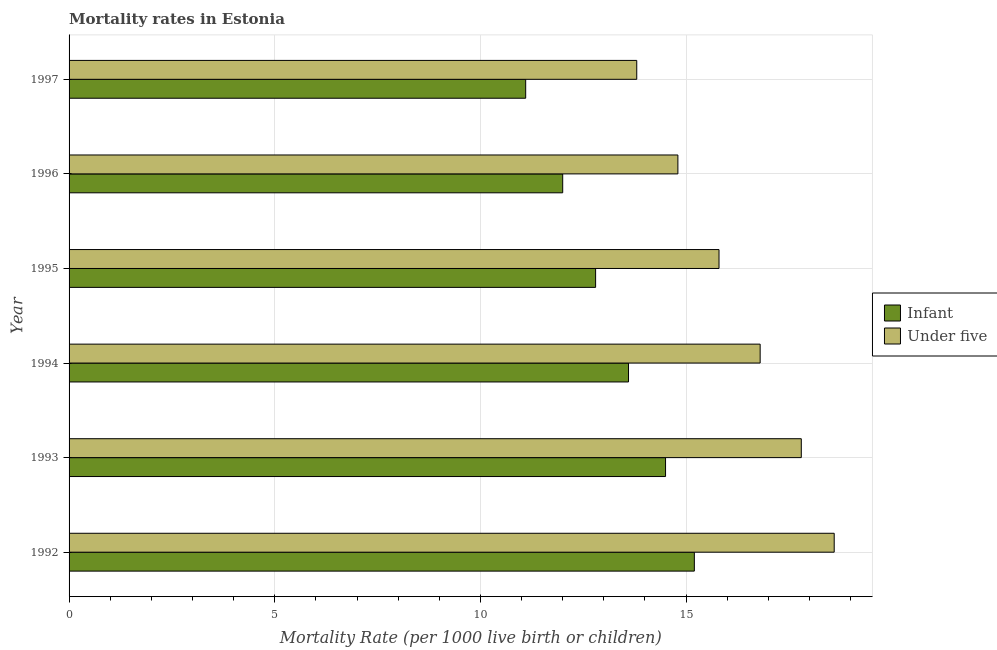How many different coloured bars are there?
Give a very brief answer. 2. Are the number of bars per tick equal to the number of legend labels?
Offer a terse response. Yes. How many bars are there on the 1st tick from the bottom?
Offer a terse response. 2. What is the under-5 mortality rate in 1995?
Ensure brevity in your answer.  15.8. In which year was the infant mortality rate maximum?
Keep it short and to the point. 1992. What is the total under-5 mortality rate in the graph?
Offer a terse response. 97.6. What is the average infant mortality rate per year?
Offer a very short reply. 13.2. What is the ratio of the infant mortality rate in 1992 to that in 1997?
Offer a terse response. 1.37. Is the difference between the under-5 mortality rate in 1992 and 1996 greater than the difference between the infant mortality rate in 1992 and 1996?
Make the answer very short. Yes. What is the difference between the highest and the second highest infant mortality rate?
Ensure brevity in your answer.  0.7. In how many years, is the under-5 mortality rate greater than the average under-5 mortality rate taken over all years?
Your answer should be very brief. 3. Is the sum of the under-5 mortality rate in 1992 and 1993 greater than the maximum infant mortality rate across all years?
Make the answer very short. Yes. What does the 1st bar from the top in 1996 represents?
Your answer should be compact. Under five. What does the 1st bar from the bottom in 1994 represents?
Your response must be concise. Infant. How many bars are there?
Give a very brief answer. 12. Are all the bars in the graph horizontal?
Give a very brief answer. Yes. Are the values on the major ticks of X-axis written in scientific E-notation?
Give a very brief answer. No. Does the graph contain any zero values?
Keep it short and to the point. No. Does the graph contain grids?
Your answer should be compact. Yes. What is the title of the graph?
Your answer should be compact. Mortality rates in Estonia. Does "current US$" appear as one of the legend labels in the graph?
Make the answer very short. No. What is the label or title of the X-axis?
Provide a succinct answer. Mortality Rate (per 1000 live birth or children). What is the Mortality Rate (per 1000 live birth or children) in Under five in 1992?
Your answer should be very brief. 18.6. What is the Mortality Rate (per 1000 live birth or children) of Infant in 1994?
Ensure brevity in your answer.  13.6. What is the Mortality Rate (per 1000 live birth or children) of Infant in 1995?
Make the answer very short. 12.8. What is the Mortality Rate (per 1000 live birth or children) in Under five in 1995?
Your answer should be compact. 15.8. What is the Mortality Rate (per 1000 live birth or children) in Infant in 1996?
Ensure brevity in your answer.  12. What is the Mortality Rate (per 1000 live birth or children) of Under five in 1996?
Give a very brief answer. 14.8. What is the Mortality Rate (per 1000 live birth or children) in Infant in 1997?
Make the answer very short. 11.1. Across all years, what is the minimum Mortality Rate (per 1000 live birth or children) in Under five?
Your answer should be compact. 13.8. What is the total Mortality Rate (per 1000 live birth or children) in Infant in the graph?
Keep it short and to the point. 79.2. What is the total Mortality Rate (per 1000 live birth or children) in Under five in the graph?
Offer a very short reply. 97.6. What is the difference between the Mortality Rate (per 1000 live birth or children) of Under five in 1992 and that in 1993?
Provide a succinct answer. 0.8. What is the difference between the Mortality Rate (per 1000 live birth or children) of Under five in 1992 and that in 1994?
Make the answer very short. 1.8. What is the difference between the Mortality Rate (per 1000 live birth or children) of Infant in 1992 and that in 1995?
Your answer should be compact. 2.4. What is the difference between the Mortality Rate (per 1000 live birth or children) in Under five in 1992 and that in 1995?
Keep it short and to the point. 2.8. What is the difference between the Mortality Rate (per 1000 live birth or children) in Under five in 1992 and that in 1996?
Provide a short and direct response. 3.8. What is the difference between the Mortality Rate (per 1000 live birth or children) of Infant in 1992 and that in 1997?
Keep it short and to the point. 4.1. What is the difference between the Mortality Rate (per 1000 live birth or children) of Infant in 1993 and that in 1994?
Offer a very short reply. 0.9. What is the difference between the Mortality Rate (per 1000 live birth or children) of Under five in 1993 and that in 1994?
Give a very brief answer. 1. What is the difference between the Mortality Rate (per 1000 live birth or children) in Infant in 1993 and that in 1995?
Provide a short and direct response. 1.7. What is the difference between the Mortality Rate (per 1000 live birth or children) of Under five in 1993 and that in 1995?
Your answer should be very brief. 2. What is the difference between the Mortality Rate (per 1000 live birth or children) of Infant in 1993 and that in 1996?
Your answer should be compact. 2.5. What is the difference between the Mortality Rate (per 1000 live birth or children) of Under five in 1993 and that in 1996?
Keep it short and to the point. 3. What is the difference between the Mortality Rate (per 1000 live birth or children) in Infant in 1993 and that in 1997?
Offer a terse response. 3.4. What is the difference between the Mortality Rate (per 1000 live birth or children) of Infant in 1994 and that in 1995?
Offer a very short reply. 0.8. What is the difference between the Mortality Rate (per 1000 live birth or children) of Under five in 1994 and that in 1996?
Your answer should be very brief. 2. What is the difference between the Mortality Rate (per 1000 live birth or children) of Infant in 1994 and that in 1997?
Your response must be concise. 2.5. What is the difference between the Mortality Rate (per 1000 live birth or children) in Under five in 1994 and that in 1997?
Provide a short and direct response. 3. What is the difference between the Mortality Rate (per 1000 live birth or children) of Infant in 1995 and that in 1996?
Make the answer very short. 0.8. What is the difference between the Mortality Rate (per 1000 live birth or children) in Under five in 1995 and that in 1996?
Your answer should be compact. 1. What is the difference between the Mortality Rate (per 1000 live birth or children) of Infant in 1995 and that in 1997?
Offer a very short reply. 1.7. What is the difference between the Mortality Rate (per 1000 live birth or children) of Under five in 1996 and that in 1997?
Your answer should be very brief. 1. What is the difference between the Mortality Rate (per 1000 live birth or children) in Infant in 1992 and the Mortality Rate (per 1000 live birth or children) in Under five in 1994?
Keep it short and to the point. -1.6. What is the difference between the Mortality Rate (per 1000 live birth or children) of Infant in 1992 and the Mortality Rate (per 1000 live birth or children) of Under five in 1995?
Your response must be concise. -0.6. What is the difference between the Mortality Rate (per 1000 live birth or children) in Infant in 1992 and the Mortality Rate (per 1000 live birth or children) in Under five in 1997?
Offer a very short reply. 1.4. What is the difference between the Mortality Rate (per 1000 live birth or children) in Infant in 1993 and the Mortality Rate (per 1000 live birth or children) in Under five in 1996?
Your answer should be very brief. -0.3. What is the difference between the Mortality Rate (per 1000 live birth or children) in Infant in 1993 and the Mortality Rate (per 1000 live birth or children) in Under five in 1997?
Keep it short and to the point. 0.7. What is the difference between the Mortality Rate (per 1000 live birth or children) of Infant in 1994 and the Mortality Rate (per 1000 live birth or children) of Under five in 1995?
Provide a short and direct response. -2.2. What is the difference between the Mortality Rate (per 1000 live birth or children) in Infant in 1994 and the Mortality Rate (per 1000 live birth or children) in Under five in 1996?
Keep it short and to the point. -1.2. What is the difference between the Mortality Rate (per 1000 live birth or children) in Infant in 1996 and the Mortality Rate (per 1000 live birth or children) in Under five in 1997?
Ensure brevity in your answer.  -1.8. What is the average Mortality Rate (per 1000 live birth or children) in Infant per year?
Your answer should be very brief. 13.2. What is the average Mortality Rate (per 1000 live birth or children) in Under five per year?
Provide a short and direct response. 16.27. In the year 1992, what is the difference between the Mortality Rate (per 1000 live birth or children) in Infant and Mortality Rate (per 1000 live birth or children) in Under five?
Your answer should be very brief. -3.4. In the year 1994, what is the difference between the Mortality Rate (per 1000 live birth or children) of Infant and Mortality Rate (per 1000 live birth or children) of Under five?
Offer a very short reply. -3.2. In the year 1995, what is the difference between the Mortality Rate (per 1000 live birth or children) in Infant and Mortality Rate (per 1000 live birth or children) in Under five?
Keep it short and to the point. -3. In the year 1996, what is the difference between the Mortality Rate (per 1000 live birth or children) in Infant and Mortality Rate (per 1000 live birth or children) in Under five?
Provide a short and direct response. -2.8. In the year 1997, what is the difference between the Mortality Rate (per 1000 live birth or children) of Infant and Mortality Rate (per 1000 live birth or children) of Under five?
Provide a succinct answer. -2.7. What is the ratio of the Mortality Rate (per 1000 live birth or children) of Infant in 1992 to that in 1993?
Your answer should be compact. 1.05. What is the ratio of the Mortality Rate (per 1000 live birth or children) in Under five in 1992 to that in 1993?
Offer a very short reply. 1.04. What is the ratio of the Mortality Rate (per 1000 live birth or children) of Infant in 1992 to that in 1994?
Keep it short and to the point. 1.12. What is the ratio of the Mortality Rate (per 1000 live birth or children) in Under five in 1992 to that in 1994?
Your answer should be very brief. 1.11. What is the ratio of the Mortality Rate (per 1000 live birth or children) of Infant in 1992 to that in 1995?
Keep it short and to the point. 1.19. What is the ratio of the Mortality Rate (per 1000 live birth or children) in Under five in 1992 to that in 1995?
Provide a short and direct response. 1.18. What is the ratio of the Mortality Rate (per 1000 live birth or children) in Infant in 1992 to that in 1996?
Your answer should be compact. 1.27. What is the ratio of the Mortality Rate (per 1000 live birth or children) in Under five in 1992 to that in 1996?
Your response must be concise. 1.26. What is the ratio of the Mortality Rate (per 1000 live birth or children) of Infant in 1992 to that in 1997?
Keep it short and to the point. 1.37. What is the ratio of the Mortality Rate (per 1000 live birth or children) in Under five in 1992 to that in 1997?
Your response must be concise. 1.35. What is the ratio of the Mortality Rate (per 1000 live birth or children) in Infant in 1993 to that in 1994?
Your answer should be very brief. 1.07. What is the ratio of the Mortality Rate (per 1000 live birth or children) in Under five in 1993 to that in 1994?
Provide a short and direct response. 1.06. What is the ratio of the Mortality Rate (per 1000 live birth or children) in Infant in 1993 to that in 1995?
Keep it short and to the point. 1.13. What is the ratio of the Mortality Rate (per 1000 live birth or children) in Under five in 1993 to that in 1995?
Your response must be concise. 1.13. What is the ratio of the Mortality Rate (per 1000 live birth or children) in Infant in 1993 to that in 1996?
Ensure brevity in your answer.  1.21. What is the ratio of the Mortality Rate (per 1000 live birth or children) of Under five in 1993 to that in 1996?
Offer a very short reply. 1.2. What is the ratio of the Mortality Rate (per 1000 live birth or children) of Infant in 1993 to that in 1997?
Your answer should be compact. 1.31. What is the ratio of the Mortality Rate (per 1000 live birth or children) of Under five in 1993 to that in 1997?
Make the answer very short. 1.29. What is the ratio of the Mortality Rate (per 1000 live birth or children) of Under five in 1994 to that in 1995?
Make the answer very short. 1.06. What is the ratio of the Mortality Rate (per 1000 live birth or children) of Infant in 1994 to that in 1996?
Provide a succinct answer. 1.13. What is the ratio of the Mortality Rate (per 1000 live birth or children) in Under five in 1994 to that in 1996?
Your response must be concise. 1.14. What is the ratio of the Mortality Rate (per 1000 live birth or children) of Infant in 1994 to that in 1997?
Give a very brief answer. 1.23. What is the ratio of the Mortality Rate (per 1000 live birth or children) in Under five in 1994 to that in 1997?
Offer a very short reply. 1.22. What is the ratio of the Mortality Rate (per 1000 live birth or children) in Infant in 1995 to that in 1996?
Give a very brief answer. 1.07. What is the ratio of the Mortality Rate (per 1000 live birth or children) in Under five in 1995 to that in 1996?
Keep it short and to the point. 1.07. What is the ratio of the Mortality Rate (per 1000 live birth or children) of Infant in 1995 to that in 1997?
Ensure brevity in your answer.  1.15. What is the ratio of the Mortality Rate (per 1000 live birth or children) in Under five in 1995 to that in 1997?
Your answer should be very brief. 1.14. What is the ratio of the Mortality Rate (per 1000 live birth or children) in Infant in 1996 to that in 1997?
Offer a very short reply. 1.08. What is the ratio of the Mortality Rate (per 1000 live birth or children) of Under five in 1996 to that in 1997?
Offer a very short reply. 1.07. What is the difference between the highest and the second highest Mortality Rate (per 1000 live birth or children) in Infant?
Provide a short and direct response. 0.7. What is the difference between the highest and the lowest Mortality Rate (per 1000 live birth or children) in Under five?
Keep it short and to the point. 4.8. 